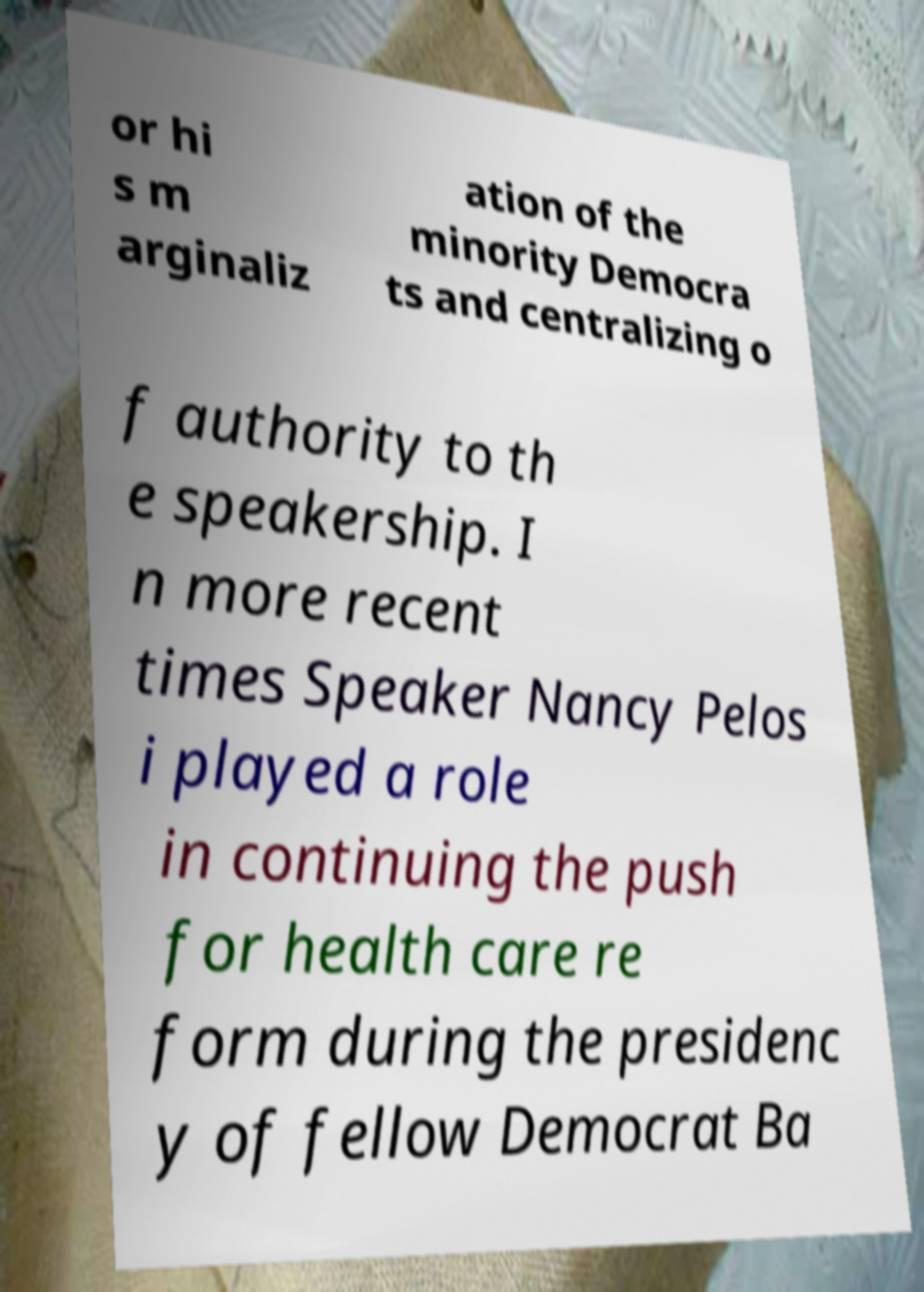Could you assist in decoding the text presented in this image and type it out clearly? or hi s m arginaliz ation of the minority Democra ts and centralizing o f authority to th e speakership. I n more recent times Speaker Nancy Pelos i played a role in continuing the push for health care re form during the presidenc y of fellow Democrat Ba 